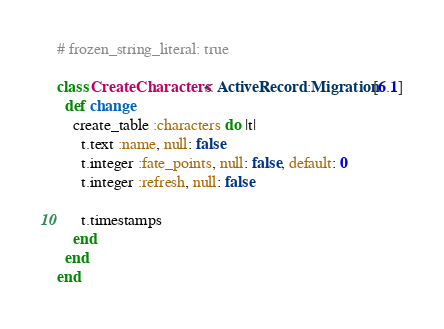<code> <loc_0><loc_0><loc_500><loc_500><_Ruby_># frozen_string_literal: true

class CreateCharacters < ActiveRecord::Migration[6.1]
  def change
    create_table :characters do |t|
      t.text :name, null: false
      t.integer :fate_points, null: false, default: 0
      t.integer :refresh, null: false

      t.timestamps
    end
  end
end
</code> 